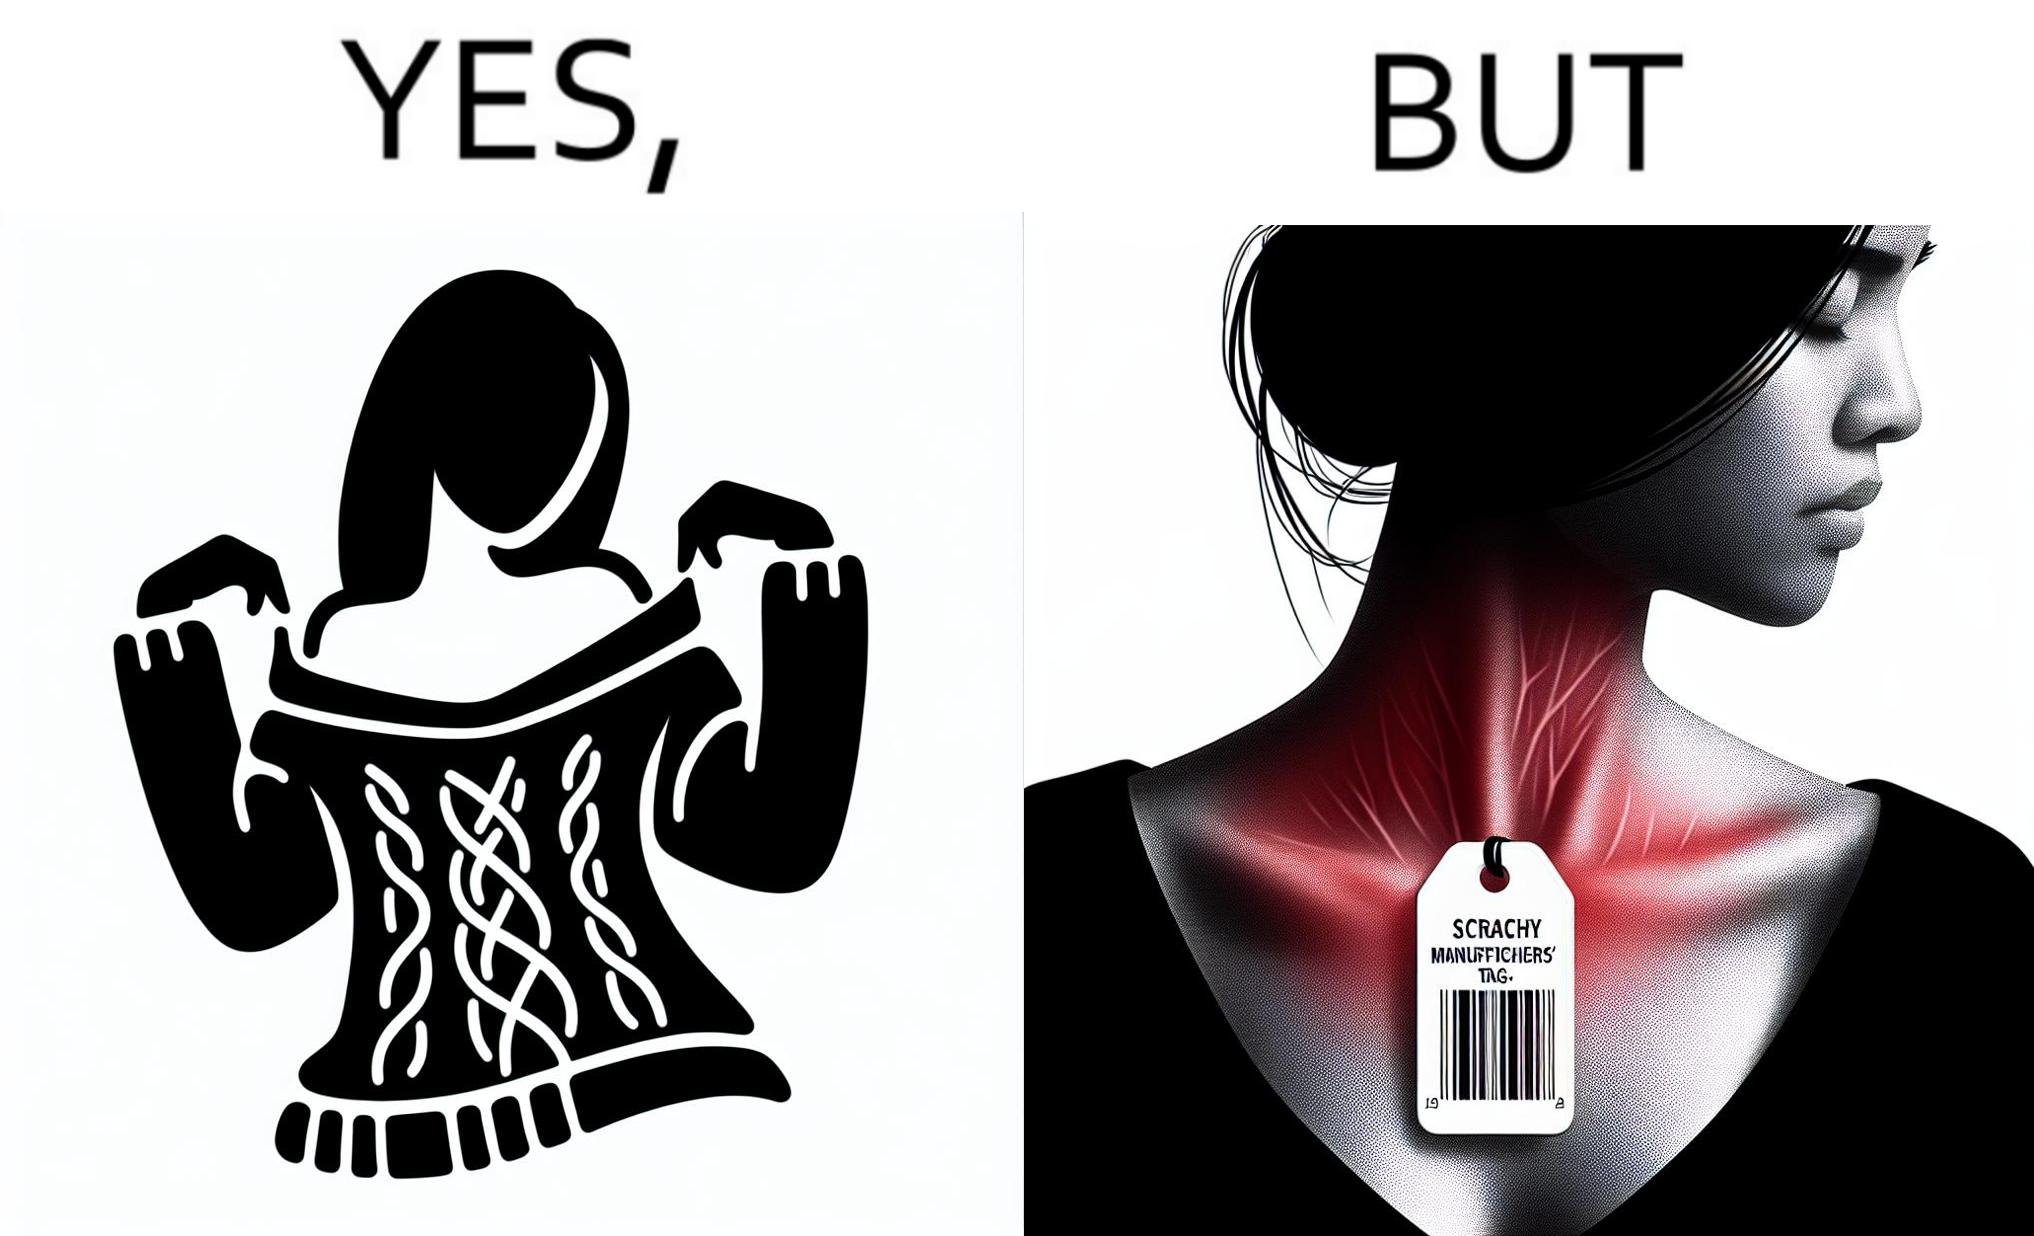What makes this image funny or satirical? The images are funny since it shows how even though sweaters and other clothings provide much comfort, a tiny manufacturers tag ends up causing the user a lot of discomfort due to constant scratching 